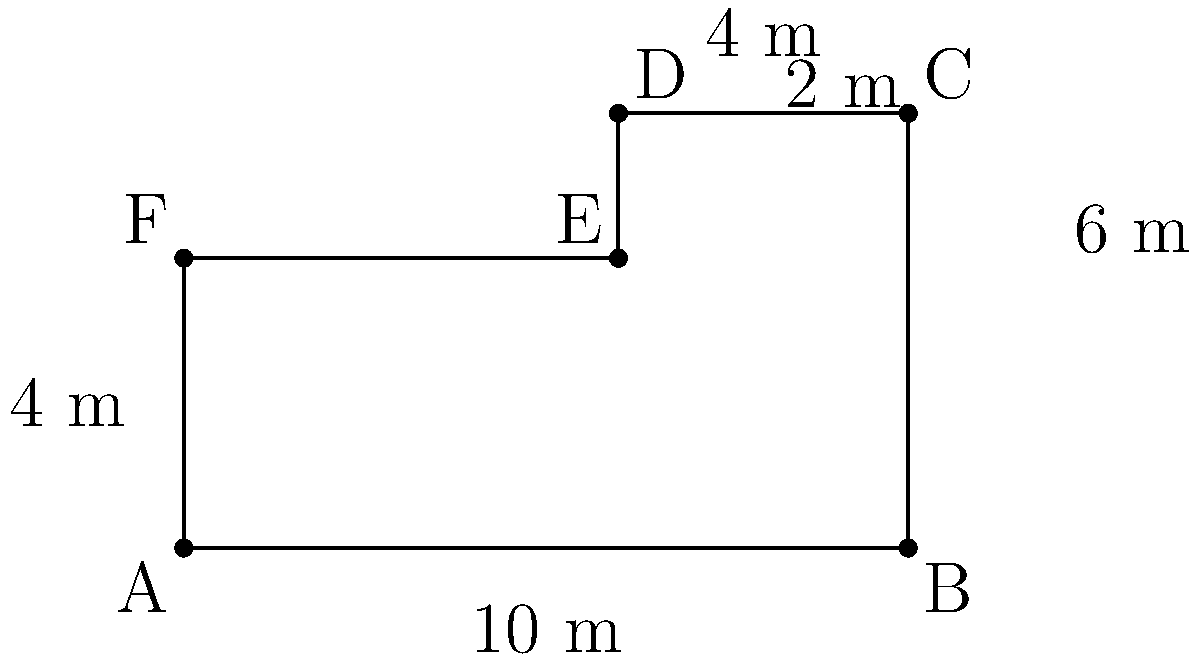You've discovered an abandoned building and managed to sketch its floor plan. Given the dimensions shown in the diagram, what is the total area of this peculiar L-shaped structure? Let's approach this step-by-step:

1) The floor plan can be divided into two rectangles: a larger one (ABEF) and a smaller one (DCDE).

2) For the larger rectangle (ABEF):
   - Length = 10 m
   - Width = 4 m
   - Area of ABEF = $10 \times 4 = 40$ m²

3) For the smaller rectangle (DCDE):
   - Length = 4 m
   - Width = 2 m
   - Area of DCDE = $4 \times 2 = 8$ m²

4) The total area is the sum of these two rectangles:
   Total Area = Area of ABEF + Area of DCDE
               = $40 + 8 = 48$ m²

Therefore, the total area of the abandoned building is 48 square meters.
Answer: 48 m² 